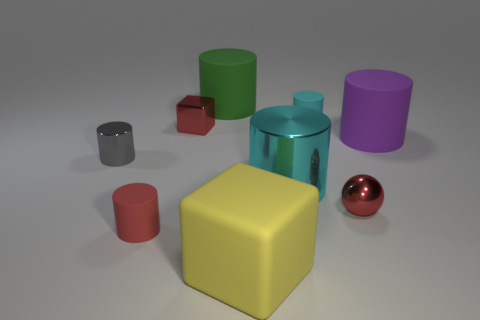Subtract all gray cylinders. How many cylinders are left? 5 Subtract all large green cylinders. How many cylinders are left? 5 Subtract all purple cylinders. Subtract all purple spheres. How many cylinders are left? 5 Add 1 gray cubes. How many objects exist? 10 Subtract all cubes. How many objects are left? 7 Subtract all tiny red shiny balls. Subtract all gray rubber blocks. How many objects are left? 8 Add 1 big purple rubber objects. How many big purple rubber objects are left? 2 Add 1 green matte cylinders. How many green matte cylinders exist? 2 Subtract 0 brown balls. How many objects are left? 9 